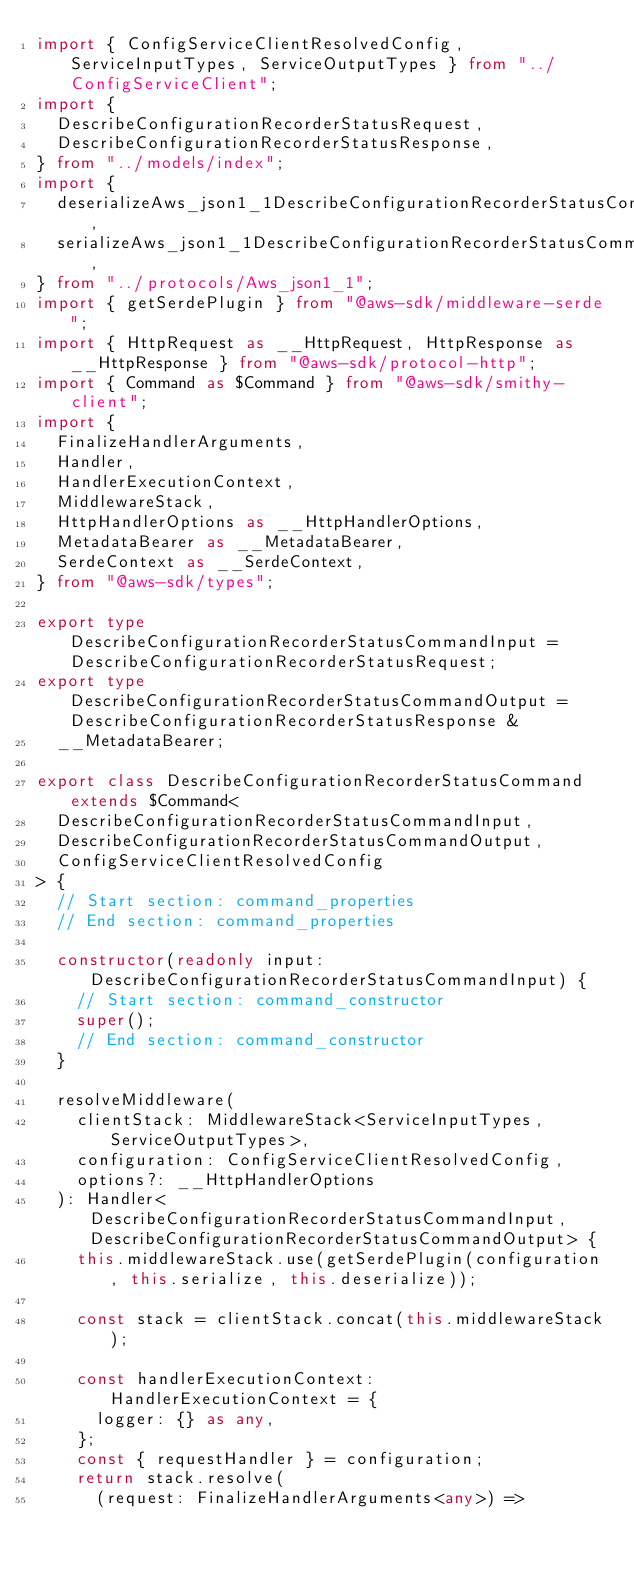Convert code to text. <code><loc_0><loc_0><loc_500><loc_500><_TypeScript_>import { ConfigServiceClientResolvedConfig, ServiceInputTypes, ServiceOutputTypes } from "../ConfigServiceClient";
import {
  DescribeConfigurationRecorderStatusRequest,
  DescribeConfigurationRecorderStatusResponse,
} from "../models/index";
import {
  deserializeAws_json1_1DescribeConfigurationRecorderStatusCommand,
  serializeAws_json1_1DescribeConfigurationRecorderStatusCommand,
} from "../protocols/Aws_json1_1";
import { getSerdePlugin } from "@aws-sdk/middleware-serde";
import { HttpRequest as __HttpRequest, HttpResponse as __HttpResponse } from "@aws-sdk/protocol-http";
import { Command as $Command } from "@aws-sdk/smithy-client";
import {
  FinalizeHandlerArguments,
  Handler,
  HandlerExecutionContext,
  MiddlewareStack,
  HttpHandlerOptions as __HttpHandlerOptions,
  MetadataBearer as __MetadataBearer,
  SerdeContext as __SerdeContext,
} from "@aws-sdk/types";

export type DescribeConfigurationRecorderStatusCommandInput = DescribeConfigurationRecorderStatusRequest;
export type DescribeConfigurationRecorderStatusCommandOutput = DescribeConfigurationRecorderStatusResponse &
  __MetadataBearer;

export class DescribeConfigurationRecorderStatusCommand extends $Command<
  DescribeConfigurationRecorderStatusCommandInput,
  DescribeConfigurationRecorderStatusCommandOutput,
  ConfigServiceClientResolvedConfig
> {
  // Start section: command_properties
  // End section: command_properties

  constructor(readonly input: DescribeConfigurationRecorderStatusCommandInput) {
    // Start section: command_constructor
    super();
    // End section: command_constructor
  }

  resolveMiddleware(
    clientStack: MiddlewareStack<ServiceInputTypes, ServiceOutputTypes>,
    configuration: ConfigServiceClientResolvedConfig,
    options?: __HttpHandlerOptions
  ): Handler<DescribeConfigurationRecorderStatusCommandInput, DescribeConfigurationRecorderStatusCommandOutput> {
    this.middlewareStack.use(getSerdePlugin(configuration, this.serialize, this.deserialize));

    const stack = clientStack.concat(this.middlewareStack);

    const handlerExecutionContext: HandlerExecutionContext = {
      logger: {} as any,
    };
    const { requestHandler } = configuration;
    return stack.resolve(
      (request: FinalizeHandlerArguments<any>) =></code> 